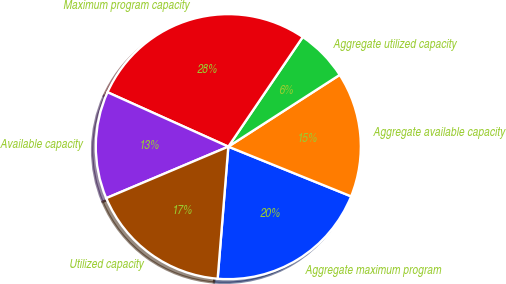<chart> <loc_0><loc_0><loc_500><loc_500><pie_chart><fcel>Aggregate maximum program<fcel>Aggregate available capacity<fcel>Aggregate utilized capacity<fcel>Maximum program capacity<fcel>Available capacity<fcel>Utilized capacity<nl><fcel>20.16%<fcel>15.23%<fcel>6.4%<fcel>27.76%<fcel>13.09%<fcel>17.36%<nl></chart> 